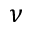Convert formula to latex. <formula><loc_0><loc_0><loc_500><loc_500>\nu</formula> 